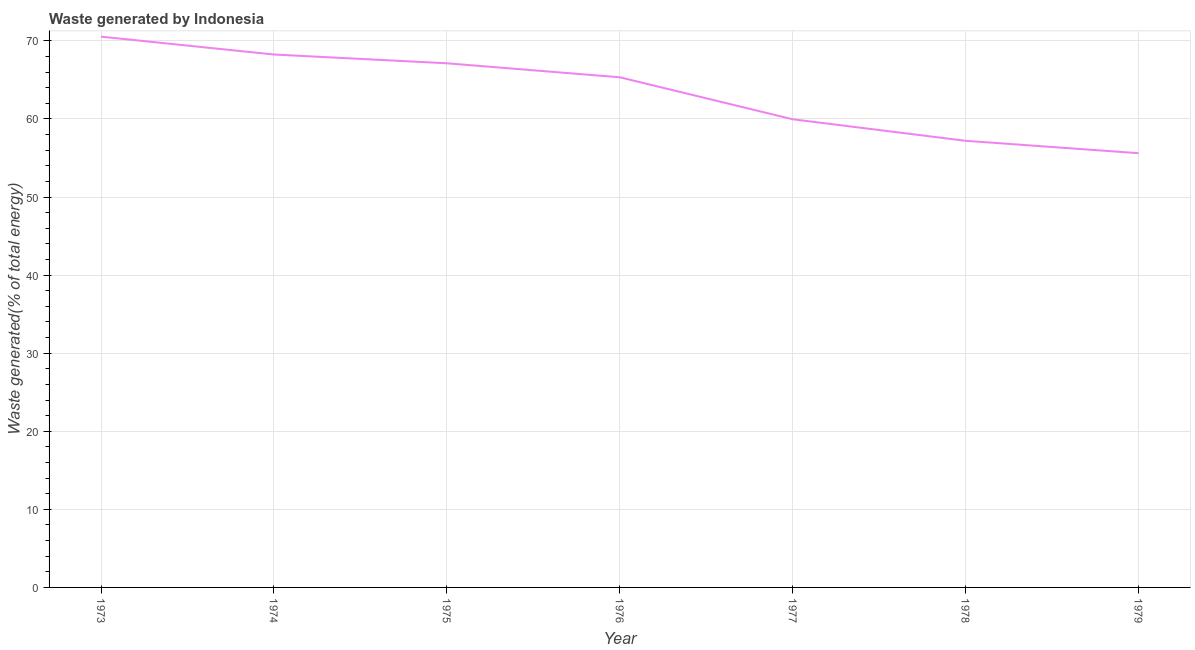What is the amount of waste generated in 1978?
Offer a very short reply. 57.2. Across all years, what is the maximum amount of waste generated?
Make the answer very short. 70.54. Across all years, what is the minimum amount of waste generated?
Give a very brief answer. 55.61. In which year was the amount of waste generated maximum?
Offer a terse response. 1973. In which year was the amount of waste generated minimum?
Ensure brevity in your answer.  1979. What is the sum of the amount of waste generated?
Your answer should be compact. 444.02. What is the difference between the amount of waste generated in 1974 and 1976?
Provide a succinct answer. 2.92. What is the average amount of waste generated per year?
Provide a short and direct response. 63.43. What is the median amount of waste generated?
Offer a very short reply. 65.33. In how many years, is the amount of waste generated greater than 36 %?
Give a very brief answer. 7. What is the ratio of the amount of waste generated in 1975 to that in 1978?
Your answer should be compact. 1.17. Is the amount of waste generated in 1974 less than that in 1979?
Provide a short and direct response. No. Is the difference between the amount of waste generated in 1974 and 1979 greater than the difference between any two years?
Your response must be concise. No. What is the difference between the highest and the second highest amount of waste generated?
Your response must be concise. 2.29. What is the difference between the highest and the lowest amount of waste generated?
Keep it short and to the point. 14.93. Does the amount of waste generated monotonically increase over the years?
Make the answer very short. No. How many years are there in the graph?
Provide a succinct answer. 7. Does the graph contain any zero values?
Make the answer very short. No. What is the title of the graph?
Offer a terse response. Waste generated by Indonesia. What is the label or title of the Y-axis?
Your answer should be very brief. Waste generated(% of total energy). What is the Waste generated(% of total energy) of 1973?
Give a very brief answer. 70.54. What is the Waste generated(% of total energy) of 1974?
Make the answer very short. 68.25. What is the Waste generated(% of total energy) of 1975?
Provide a succinct answer. 67.13. What is the Waste generated(% of total energy) of 1976?
Provide a short and direct response. 65.33. What is the Waste generated(% of total energy) of 1977?
Provide a short and direct response. 59.96. What is the Waste generated(% of total energy) of 1978?
Ensure brevity in your answer.  57.2. What is the Waste generated(% of total energy) in 1979?
Keep it short and to the point. 55.61. What is the difference between the Waste generated(% of total energy) in 1973 and 1974?
Offer a terse response. 2.29. What is the difference between the Waste generated(% of total energy) in 1973 and 1975?
Ensure brevity in your answer.  3.41. What is the difference between the Waste generated(% of total energy) in 1973 and 1976?
Your answer should be compact. 5.2. What is the difference between the Waste generated(% of total energy) in 1973 and 1977?
Your answer should be very brief. 10.58. What is the difference between the Waste generated(% of total energy) in 1973 and 1978?
Offer a very short reply. 13.34. What is the difference between the Waste generated(% of total energy) in 1973 and 1979?
Offer a very short reply. 14.93. What is the difference between the Waste generated(% of total energy) in 1974 and 1975?
Your answer should be very brief. 1.12. What is the difference between the Waste generated(% of total energy) in 1974 and 1976?
Keep it short and to the point. 2.92. What is the difference between the Waste generated(% of total energy) in 1974 and 1977?
Provide a succinct answer. 8.3. What is the difference between the Waste generated(% of total energy) in 1974 and 1978?
Your response must be concise. 11.05. What is the difference between the Waste generated(% of total energy) in 1974 and 1979?
Offer a terse response. 12.64. What is the difference between the Waste generated(% of total energy) in 1975 and 1976?
Your answer should be compact. 1.79. What is the difference between the Waste generated(% of total energy) in 1975 and 1977?
Offer a terse response. 7.17. What is the difference between the Waste generated(% of total energy) in 1975 and 1978?
Your answer should be compact. 9.93. What is the difference between the Waste generated(% of total energy) in 1975 and 1979?
Provide a succinct answer. 11.52. What is the difference between the Waste generated(% of total energy) in 1976 and 1977?
Your response must be concise. 5.38. What is the difference between the Waste generated(% of total energy) in 1976 and 1978?
Offer a very short reply. 8.13. What is the difference between the Waste generated(% of total energy) in 1976 and 1979?
Provide a short and direct response. 9.72. What is the difference between the Waste generated(% of total energy) in 1977 and 1978?
Offer a terse response. 2.76. What is the difference between the Waste generated(% of total energy) in 1977 and 1979?
Your response must be concise. 4.34. What is the difference between the Waste generated(% of total energy) in 1978 and 1979?
Your answer should be very brief. 1.59. What is the ratio of the Waste generated(% of total energy) in 1973 to that in 1974?
Give a very brief answer. 1.03. What is the ratio of the Waste generated(% of total energy) in 1973 to that in 1975?
Offer a very short reply. 1.05. What is the ratio of the Waste generated(% of total energy) in 1973 to that in 1976?
Provide a short and direct response. 1.08. What is the ratio of the Waste generated(% of total energy) in 1973 to that in 1977?
Your answer should be very brief. 1.18. What is the ratio of the Waste generated(% of total energy) in 1973 to that in 1978?
Your response must be concise. 1.23. What is the ratio of the Waste generated(% of total energy) in 1973 to that in 1979?
Your response must be concise. 1.27. What is the ratio of the Waste generated(% of total energy) in 1974 to that in 1976?
Give a very brief answer. 1.04. What is the ratio of the Waste generated(% of total energy) in 1974 to that in 1977?
Your answer should be compact. 1.14. What is the ratio of the Waste generated(% of total energy) in 1974 to that in 1978?
Your answer should be very brief. 1.19. What is the ratio of the Waste generated(% of total energy) in 1974 to that in 1979?
Provide a short and direct response. 1.23. What is the ratio of the Waste generated(% of total energy) in 1975 to that in 1976?
Make the answer very short. 1.03. What is the ratio of the Waste generated(% of total energy) in 1975 to that in 1977?
Ensure brevity in your answer.  1.12. What is the ratio of the Waste generated(% of total energy) in 1975 to that in 1978?
Make the answer very short. 1.17. What is the ratio of the Waste generated(% of total energy) in 1975 to that in 1979?
Your answer should be very brief. 1.21. What is the ratio of the Waste generated(% of total energy) in 1976 to that in 1977?
Make the answer very short. 1.09. What is the ratio of the Waste generated(% of total energy) in 1976 to that in 1978?
Provide a short and direct response. 1.14. What is the ratio of the Waste generated(% of total energy) in 1976 to that in 1979?
Offer a very short reply. 1.18. What is the ratio of the Waste generated(% of total energy) in 1977 to that in 1978?
Your answer should be very brief. 1.05. What is the ratio of the Waste generated(% of total energy) in 1977 to that in 1979?
Provide a succinct answer. 1.08. What is the ratio of the Waste generated(% of total energy) in 1978 to that in 1979?
Your response must be concise. 1.03. 